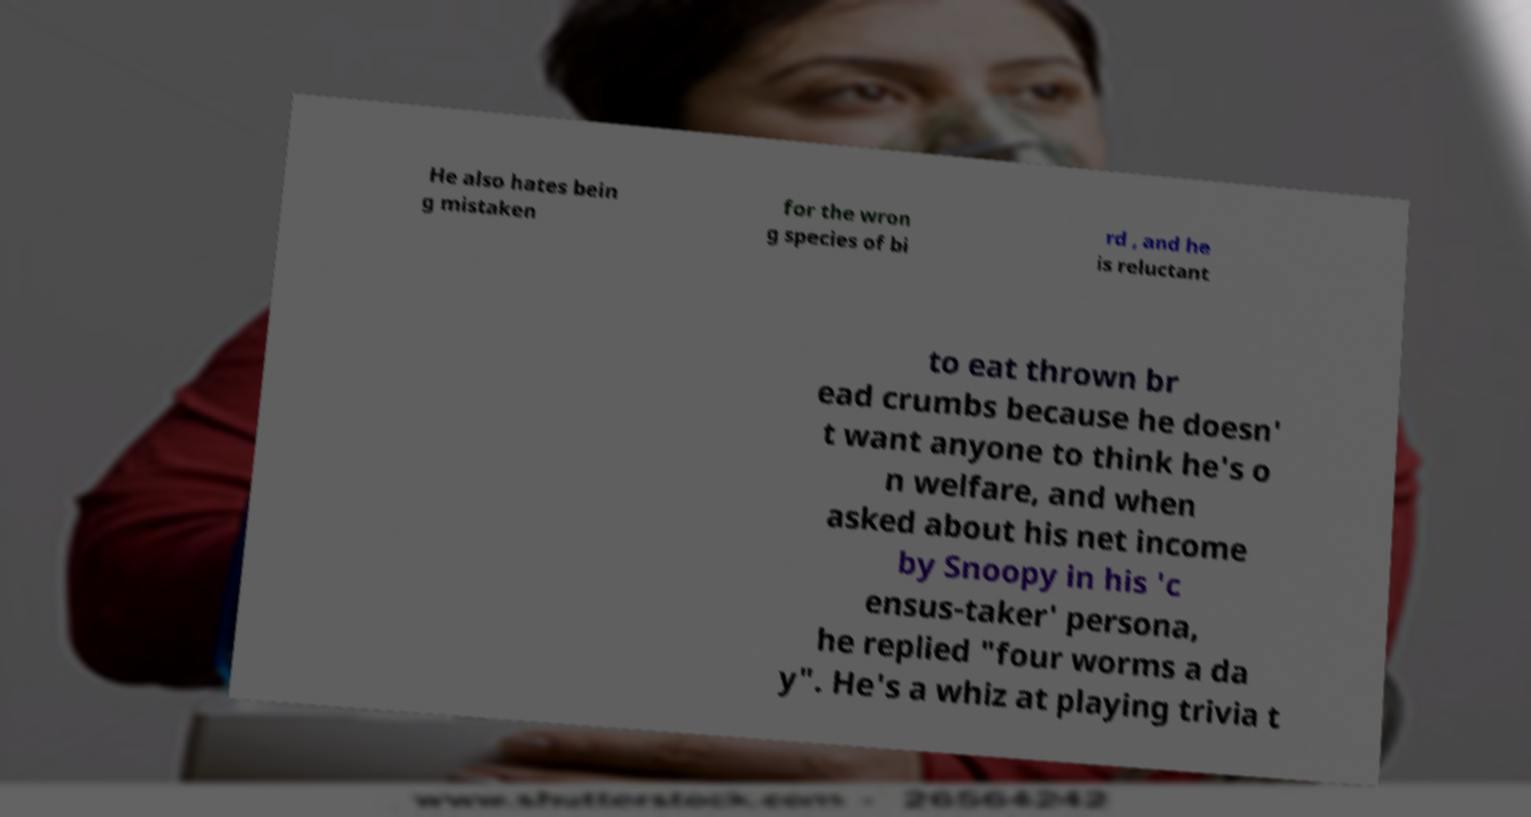For documentation purposes, I need the text within this image transcribed. Could you provide that? He also hates bein g mistaken for the wron g species of bi rd , and he is reluctant to eat thrown br ead crumbs because he doesn' t want anyone to think he's o n welfare, and when asked about his net income by Snoopy in his 'c ensus-taker' persona, he replied "four worms a da y". He's a whiz at playing trivia t 